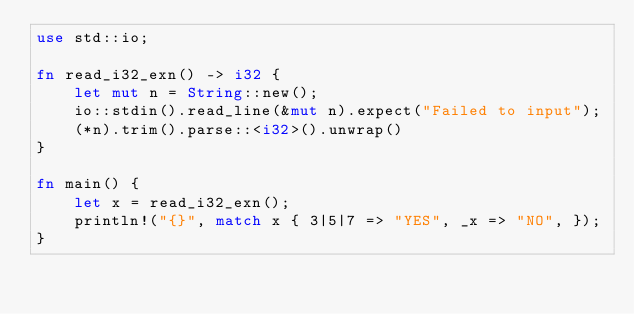Convert code to text. <code><loc_0><loc_0><loc_500><loc_500><_Rust_>use std::io;

fn read_i32_exn() -> i32 {
    let mut n = String::new();
    io::stdin().read_line(&mut n).expect("Failed to input");
    (*n).trim().parse::<i32>().unwrap()
}

fn main() {
    let x = read_i32_exn();
    println!("{}", match x { 3|5|7 => "YES", _x => "NO", });
}
</code> 